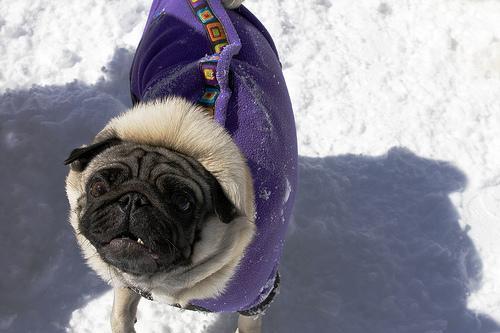How many dogs are in the photo?
Give a very brief answer. 1. 